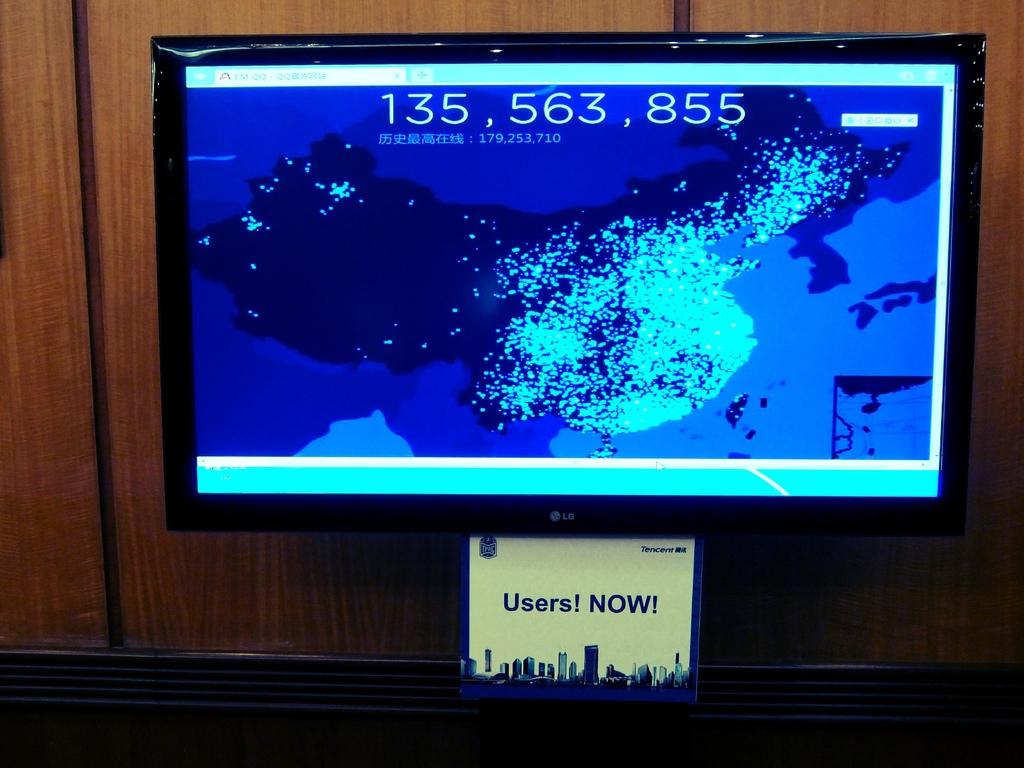What does it say below?
Ensure brevity in your answer.  Users! now!. 